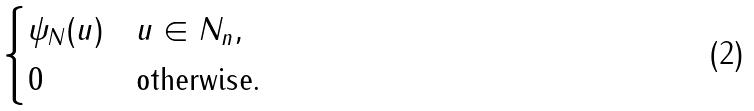Convert formula to latex. <formula><loc_0><loc_0><loc_500><loc_500>\begin{cases} \psi _ { N } ( u ) & u \in N _ { n } , \\ 0 & \text {otherwise.} \end{cases}</formula> 